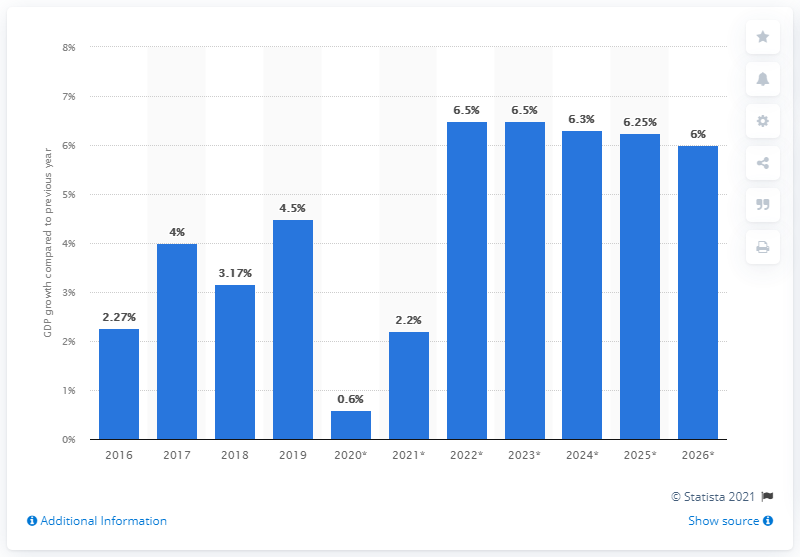Outline some significant characteristics in this image. According to recent estimates, Malawi's gross domestic product (GDP) grew by 0.6% in 2020. 